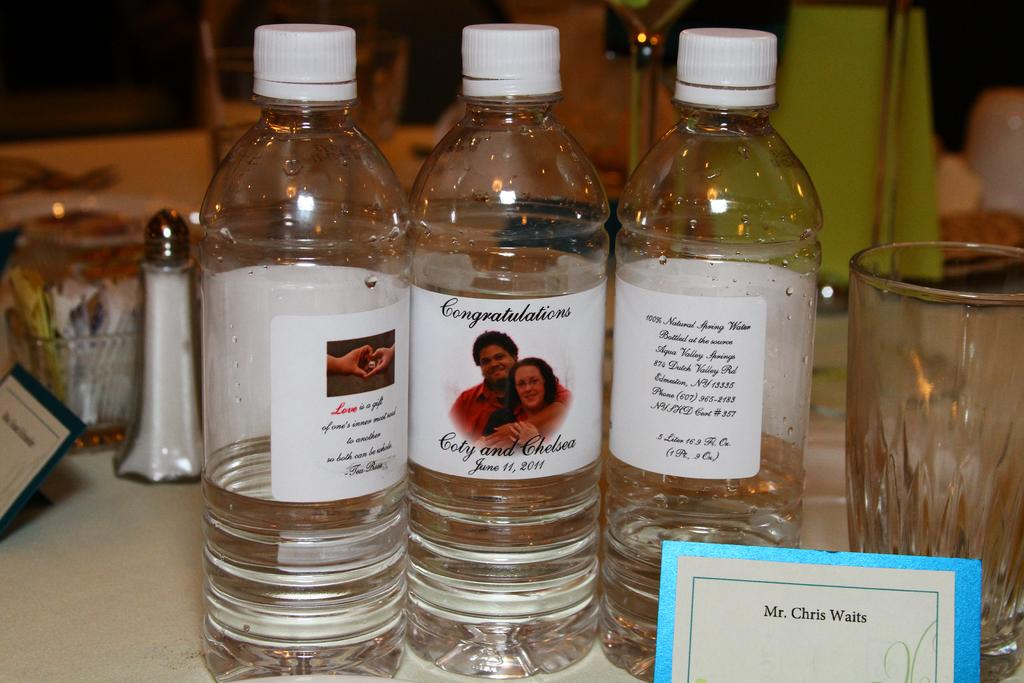<image>
Relay a brief, clear account of the picture shown. Bottles of water that say Congratulations Coty and Chelsea. 